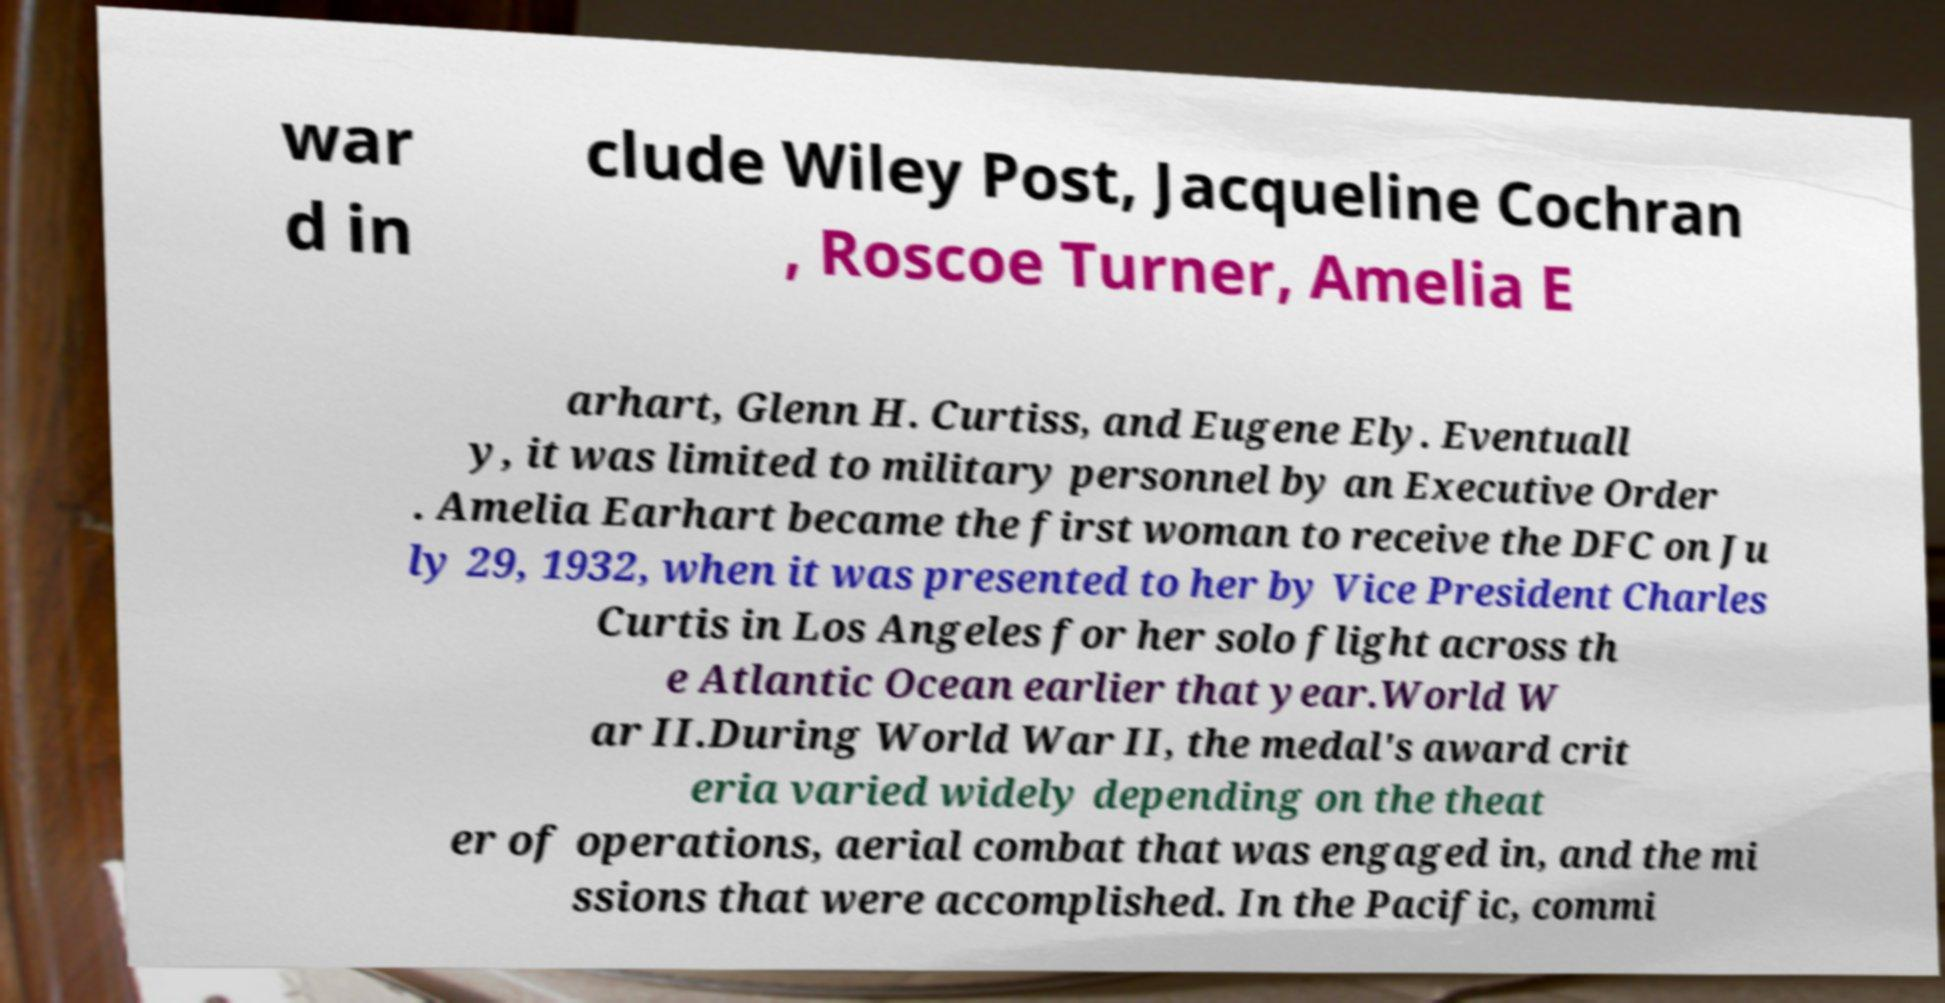Can you read and provide the text displayed in the image?This photo seems to have some interesting text. Can you extract and type it out for me? war d in clude Wiley Post, Jacqueline Cochran , Roscoe Turner, Amelia E arhart, Glenn H. Curtiss, and Eugene Ely. Eventuall y, it was limited to military personnel by an Executive Order . Amelia Earhart became the first woman to receive the DFC on Ju ly 29, 1932, when it was presented to her by Vice President Charles Curtis in Los Angeles for her solo flight across th e Atlantic Ocean earlier that year.World W ar II.During World War II, the medal's award crit eria varied widely depending on the theat er of operations, aerial combat that was engaged in, and the mi ssions that were accomplished. In the Pacific, commi 